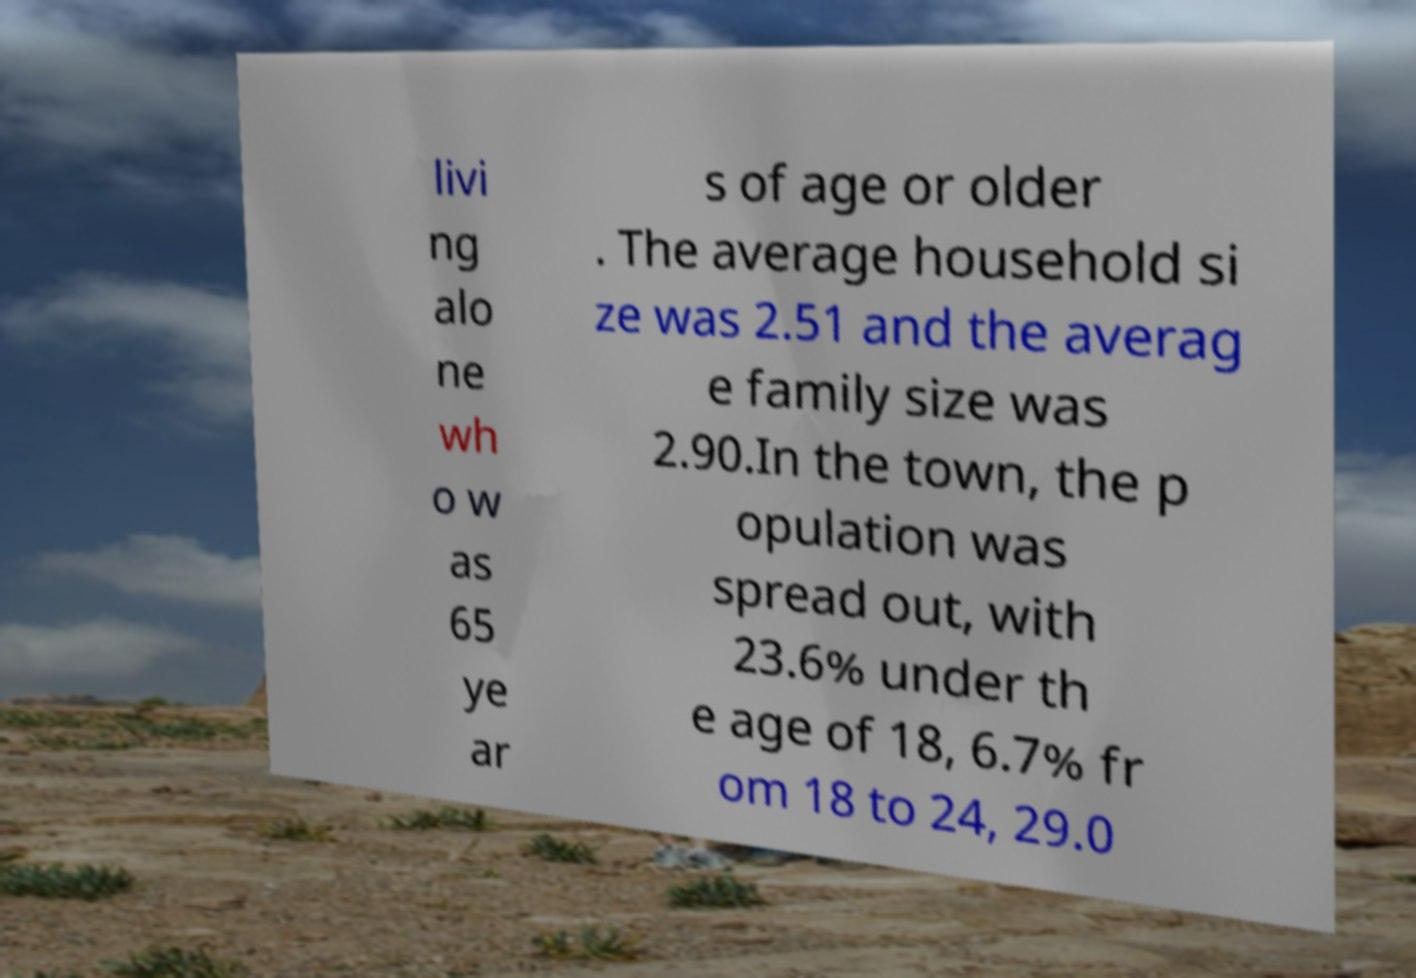For documentation purposes, I need the text within this image transcribed. Could you provide that? livi ng alo ne wh o w as 65 ye ar s of age or older . The average household si ze was 2.51 and the averag e family size was 2.90.In the town, the p opulation was spread out, with 23.6% under th e age of 18, 6.7% fr om 18 to 24, 29.0 